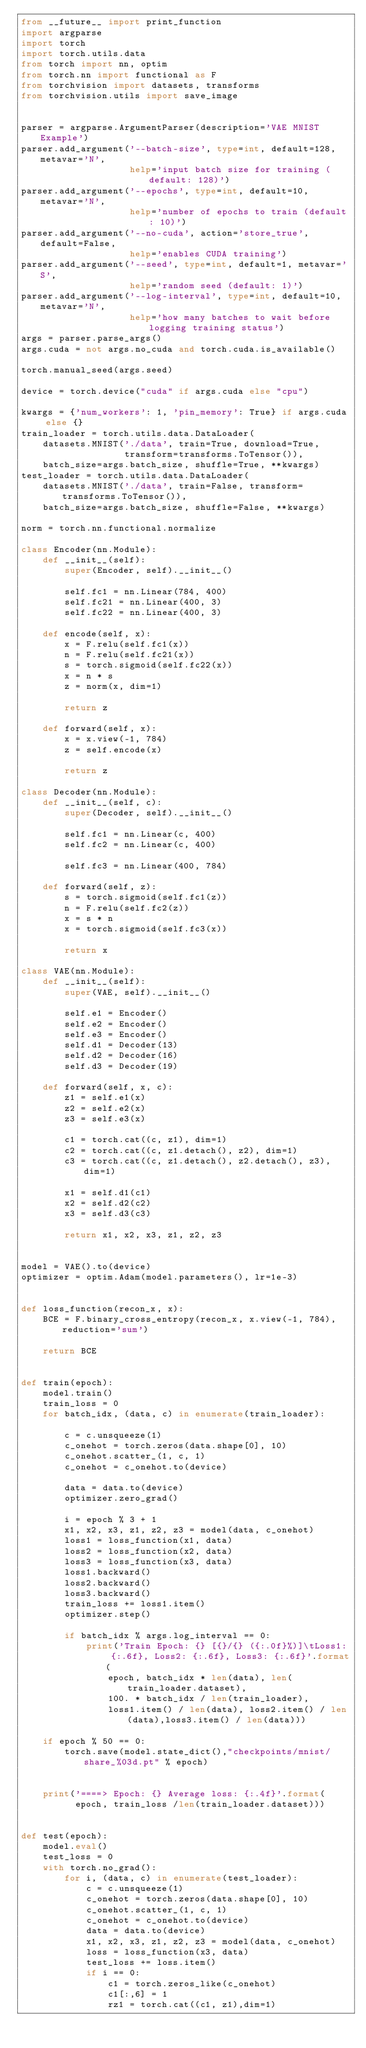Convert code to text. <code><loc_0><loc_0><loc_500><loc_500><_Python_>from __future__ import print_function
import argparse
import torch
import torch.utils.data
from torch import nn, optim
from torch.nn import functional as F
from torchvision import datasets, transforms
from torchvision.utils import save_image


parser = argparse.ArgumentParser(description='VAE MNIST Example')
parser.add_argument('--batch-size', type=int, default=128, metavar='N',
                    help='input batch size for training (default: 128)')
parser.add_argument('--epochs', type=int, default=10, metavar='N',
                    help='number of epochs to train (default: 10)')
parser.add_argument('--no-cuda', action='store_true', default=False,
                    help='enables CUDA training')
parser.add_argument('--seed', type=int, default=1, metavar='S',
                    help='random seed (default: 1)')
parser.add_argument('--log-interval', type=int, default=10, metavar='N',
                    help='how many batches to wait before logging training status')
args = parser.parse_args()
args.cuda = not args.no_cuda and torch.cuda.is_available()

torch.manual_seed(args.seed)

device = torch.device("cuda" if args.cuda else "cpu")

kwargs = {'num_workers': 1, 'pin_memory': True} if args.cuda else {}
train_loader = torch.utils.data.DataLoader(
    datasets.MNIST('./data', train=True, download=True,
                   transform=transforms.ToTensor()),
    batch_size=args.batch_size, shuffle=True, **kwargs)
test_loader = torch.utils.data.DataLoader(
    datasets.MNIST('./data', train=False, transform=transforms.ToTensor()),
    batch_size=args.batch_size, shuffle=False, **kwargs)

norm = torch.nn.functional.normalize

class Encoder(nn.Module):
    def __init__(self):
        super(Encoder, self).__init__()

        self.fc1 = nn.Linear(784, 400)
        self.fc21 = nn.Linear(400, 3)
        self.fc22 = nn.Linear(400, 3)

    def encode(self, x):
        x = F.relu(self.fc1(x))
        n = F.relu(self.fc21(x))
        s = torch.sigmoid(self.fc22(x))
        x = n * s
        z = norm(x, dim=1)
        
        return z

    def forward(self, x):
        x = x.view(-1, 784)
        z = self.encode(x)
       
        return z

class Decoder(nn.Module):
    def __init__(self, c):
        super(Decoder, self).__init__()

        self.fc1 = nn.Linear(c, 400)
        self.fc2 = nn.Linear(c, 400)
       
        self.fc3 = nn.Linear(400, 784)

    def forward(self, z):
        s = torch.sigmoid(self.fc1(z))
        n = F.relu(self.fc2(z))
        x = s * n
        x = torch.sigmoid(self.fc3(x))
       
        return x 

class VAE(nn.Module):
    def __init__(self):
        super(VAE, self).__init__()

        self.e1 = Encoder()
        self.e2 = Encoder()
        self.e3 = Encoder()
        self.d1 = Decoder(13)
        self.d2 = Decoder(16)
        self.d3 = Decoder(19)

    def forward(self, x, c):
        z1 = self.e1(x)
        z2 = self.e2(x)
        z3 = self.e3(x)

        c1 = torch.cat((c, z1), dim=1)
        c2 = torch.cat((c, z1.detach(), z2), dim=1)
        c3 = torch.cat((c, z1.detach(), z2.detach(), z3), dim=1)

        x1 = self.d1(c1)
        x2 = self.d2(c2)
        x3 = self.d3(c3)

        return x1, x2, x3, z1, z2, z3


model = VAE().to(device)
optimizer = optim.Adam(model.parameters(), lr=1e-3)


def loss_function(recon_x, x):
    BCE = F.binary_cross_entropy(recon_x, x.view(-1, 784), reduction='sum')

    return BCE


def train(epoch):
    model.train()
    train_loss = 0
    for batch_idx, (data, c) in enumerate(train_loader):

        c = c.unsqueeze(1)
        c_onehot = torch.zeros(data.shape[0], 10)
        c_onehot.scatter_(1, c, 1)
        c_onehot = c_onehot.to(device)

        data = data.to(device)
        optimizer.zero_grad()
        
        i = epoch % 3 + 1
        x1, x2, x3, z1, z2, z3 = model(data, c_onehot) 
        loss1 = loss_function(x1, data)
        loss2 = loss_function(x2, data)
        loss3 = loss_function(x3, data)
        loss1.backward()
        loss2.backward()
        loss3.backward()
        train_loss += loss1.item()
        optimizer.step()

        if batch_idx % args.log_interval == 0:
            print('Train Epoch: {} [{}/{} ({:.0f}%)]\tLoss1: {:.6f}, Loss2: {:.6f}, Loss3: {:.6f}'.format(
                epoch, batch_idx * len(data), len(train_loader.dataset),
                100. * batch_idx / len(train_loader),
                loss1.item() / len(data), loss2.item() / len(data),loss3.item() / len(data)))

    if epoch % 50 == 0:
        torch.save(model.state_dict(),"checkpoints/mnist/share_%03d.pt" % epoch)
    

    print('====> Epoch: {} Average loss: {:.4f}'.format(
          epoch, train_loss /len(train_loader.dataset)))


def test(epoch):
    model.eval()
    test_loss = 0
    with torch.no_grad():
        for i, (data, c) in enumerate(test_loader):
            c = c.unsqueeze(1)
            c_onehot = torch.zeros(data.shape[0], 10)
            c_onehot.scatter_(1, c, 1)
            c_onehot = c_onehot.to(device)
            data = data.to(device)
            x1, x2, x3, z1, z2, z3 = model(data, c_onehot)
            loss = loss_function(x3, data)
            test_loss += loss.item()
            if i == 0:
                c1 = torch.zeros_like(c_onehot)
                c1[:,6] = 1
                rz1 = torch.cat((c1, z1),dim=1)</code> 